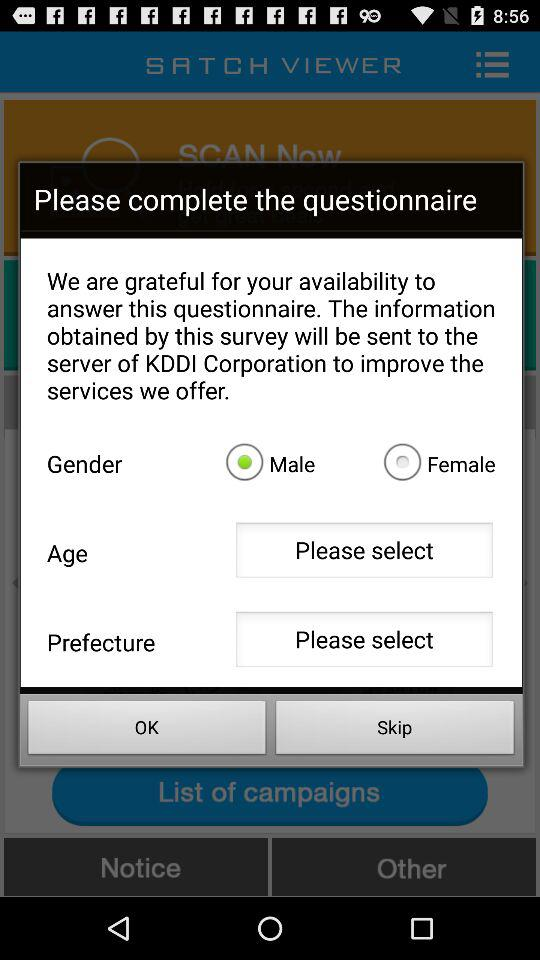Which gender is selected? The selected gender is male. 